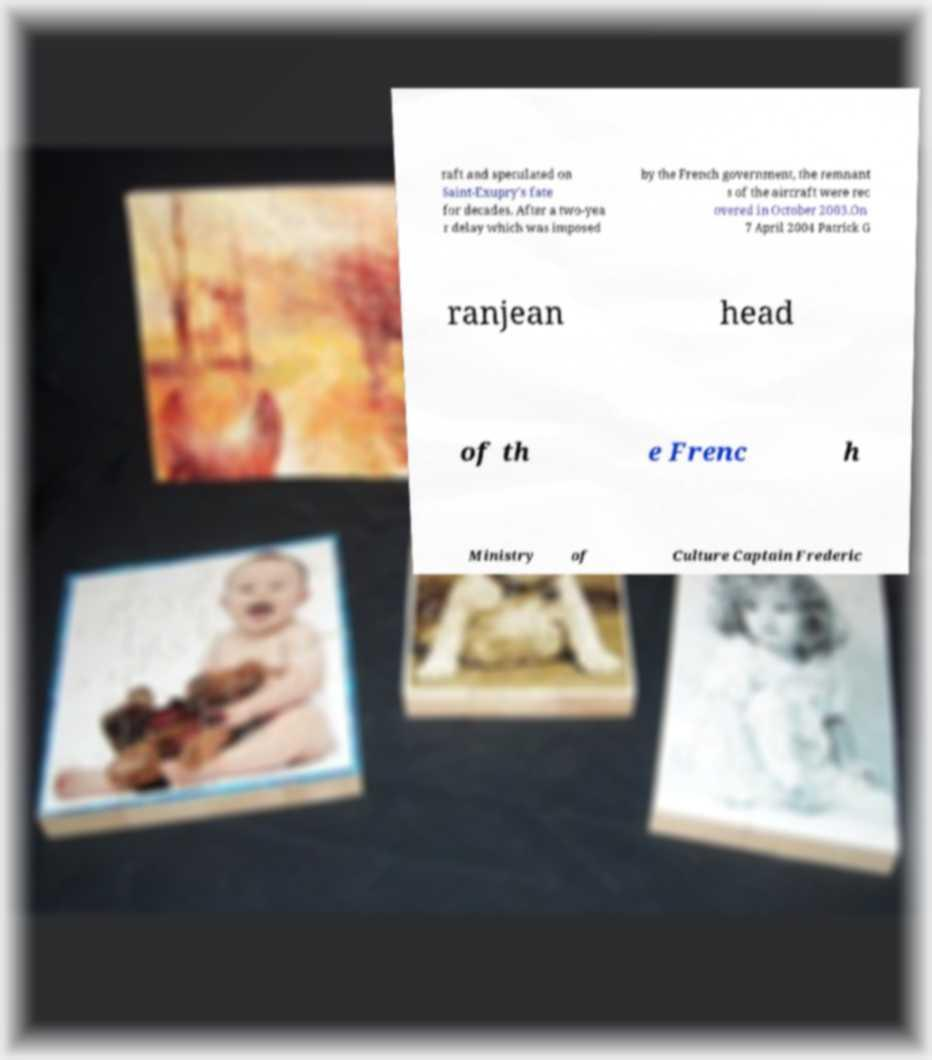Please read and relay the text visible in this image. What does it say? raft and speculated on Saint-Exupry's fate for decades. After a two-yea r delay which was imposed by the French government, the remnant s of the aircraft were rec overed in October 2003.On 7 April 2004 Patrick G ranjean head of th e Frenc h Ministry of Culture Captain Frederic 